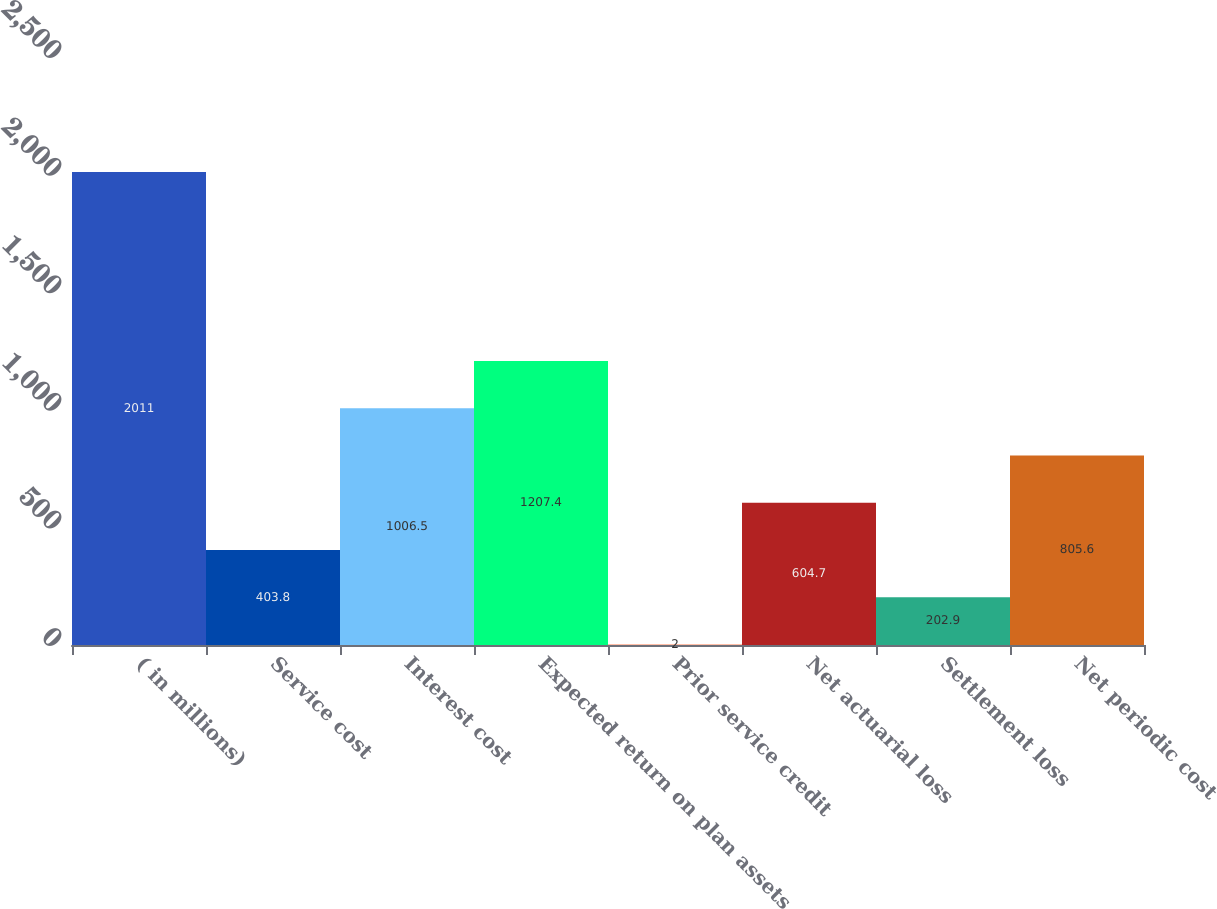<chart> <loc_0><loc_0><loc_500><loc_500><bar_chart><fcel>( in millions)<fcel>Service cost<fcel>Interest cost<fcel>Expected return on plan assets<fcel>Prior service credit<fcel>Net actuarial loss<fcel>Settlement loss<fcel>Net periodic cost<nl><fcel>2011<fcel>403.8<fcel>1006.5<fcel>1207.4<fcel>2<fcel>604.7<fcel>202.9<fcel>805.6<nl></chart> 